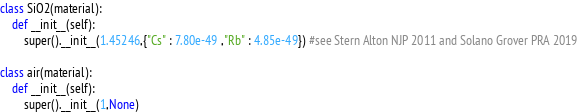<code> <loc_0><loc_0><loc_500><loc_500><_Python_>class SiO2(material):
    def __init__(self):
        super().__init__(1.45246,{"Cs" : 7.80e-49 ,"Rb" : 4.85e-49}) #see Stern Alton NJP 2011 and Solano Grover PRA 2019
    
class air(material):
    def __init__(self):
        super().__init__(1,None)
</code> 